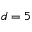Convert formula to latex. <formula><loc_0><loc_0><loc_500><loc_500>d = 5</formula> 